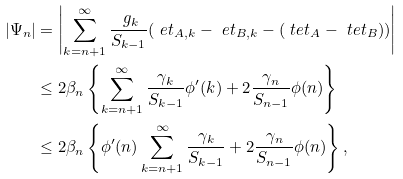<formula> <loc_0><loc_0><loc_500><loc_500>| \Psi _ { n } | & = \left | \sum _ { k = n + 1 } ^ { \infty } \frac { \ g _ { k } } { S _ { k - 1 } } ( \ e t _ { A , k } - \ e t _ { B , k } - ( \ t e t _ { A } - \ t e t _ { B } ) ) \right | \\ & \leq 2 \beta _ { n } \left \{ \sum _ { k = n + 1 } ^ { \infty } \frac { \gamma _ { k } } { S _ { k - 1 } } \phi ^ { \prime } ( k ) + 2 \frac { \gamma _ { n } } { S _ { n - 1 } } \phi ( n ) \right \} \\ & \leq 2 \beta _ { n } \left \{ \phi ^ { \prime } ( n ) \sum _ { k = n + 1 } ^ { \infty } \frac { \gamma _ { k } } { S _ { k - 1 } } + 2 \frac { \gamma _ { n } } { S _ { n - 1 } } \phi ( n ) \right \} ,</formula> 